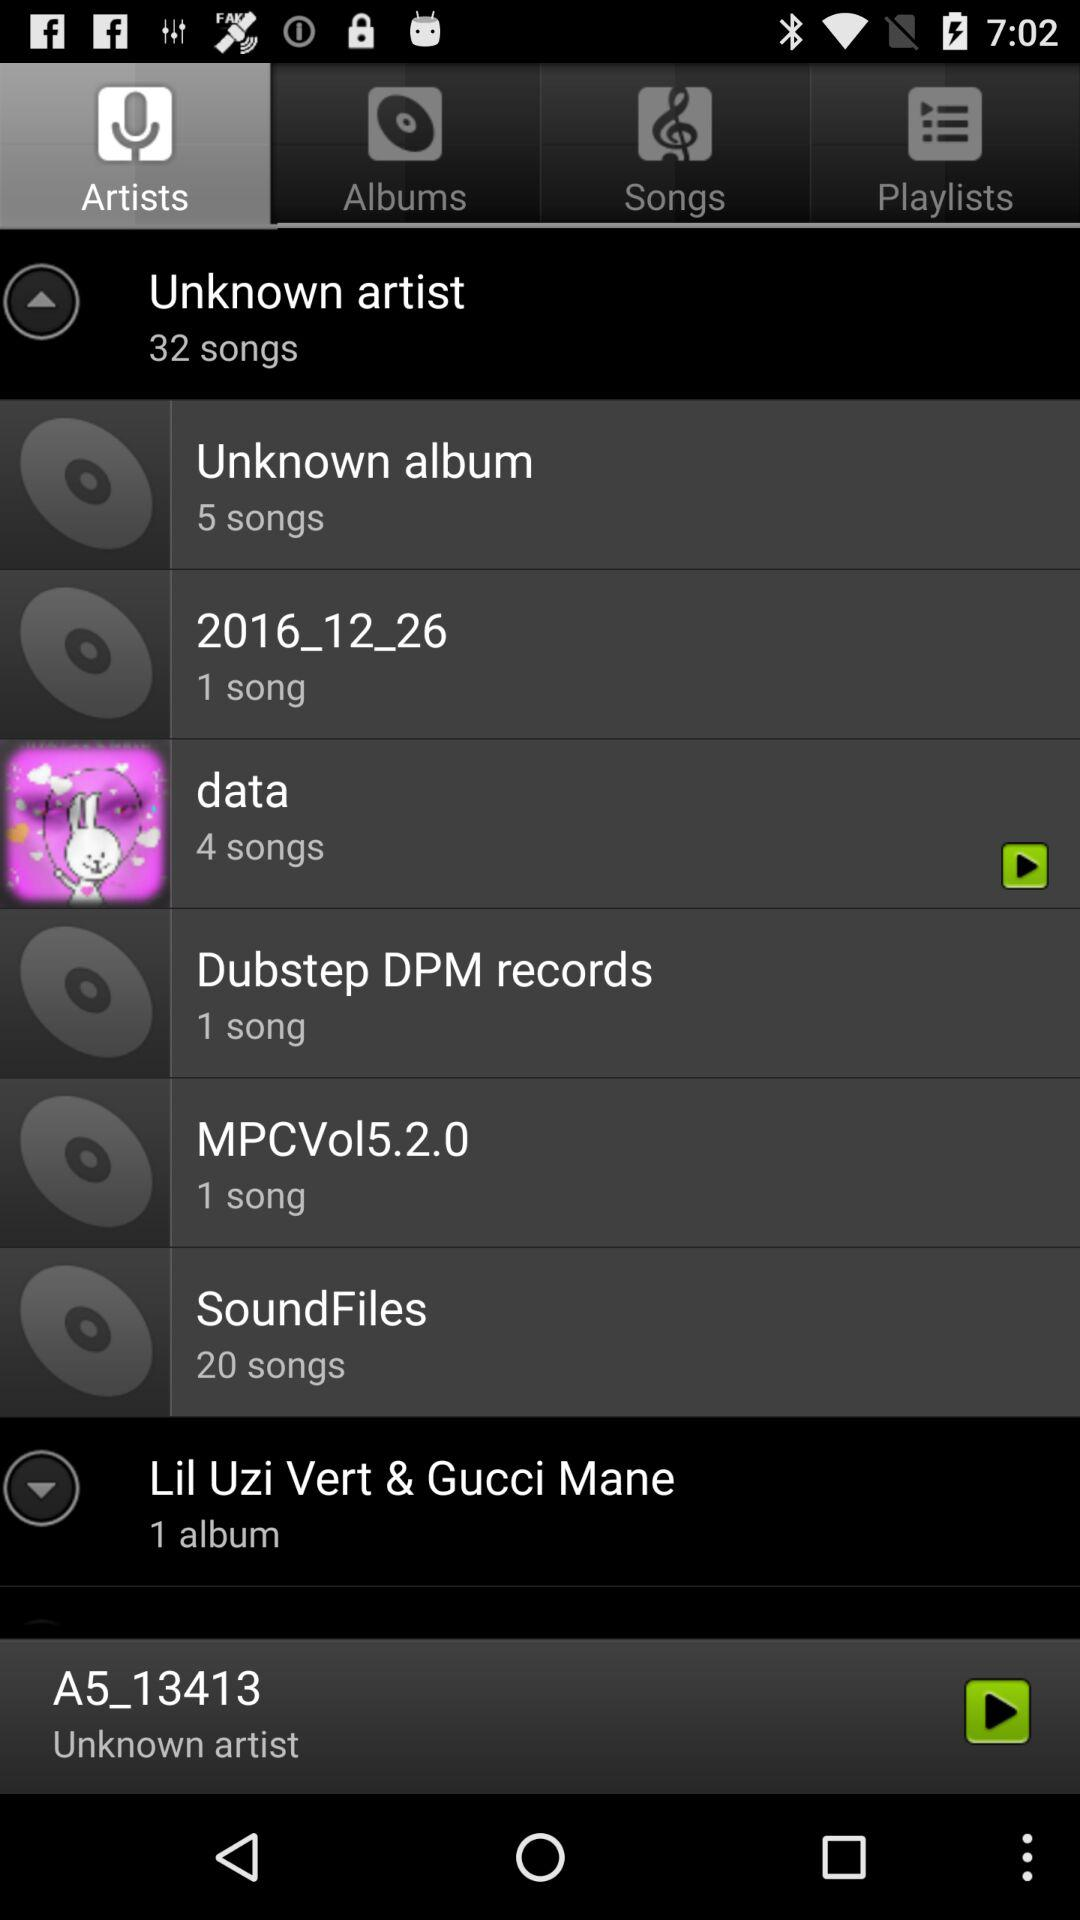How many songs are there in "SoundFiles"? There are 20 songs. 